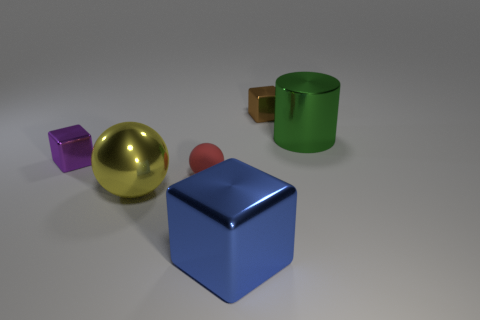Subtract all tiny metal blocks. How many blocks are left? 1 Add 4 purple metal things. How many objects exist? 10 Subtract all balls. How many objects are left? 4 Subtract 0 green blocks. How many objects are left? 6 Subtract all red metallic cylinders. Subtract all tiny red balls. How many objects are left? 5 Add 3 tiny metal cubes. How many tiny metal cubes are left? 5 Add 2 green metallic cubes. How many green metallic cubes exist? 2 